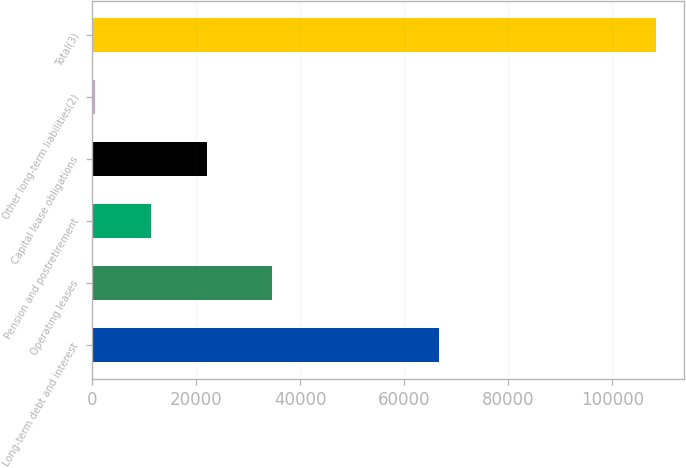Convert chart to OTSL. <chart><loc_0><loc_0><loc_500><loc_500><bar_chart><fcel>Long-term debt and interest<fcel>Operating leases<fcel>Pension and postretirement<fcel>Capital lease obligations<fcel>Other long-term liabilities(2)<fcel>Total(3)<nl><fcel>66712<fcel>34590<fcel>11247.3<fcel>22042.6<fcel>452<fcel>108405<nl></chart> 